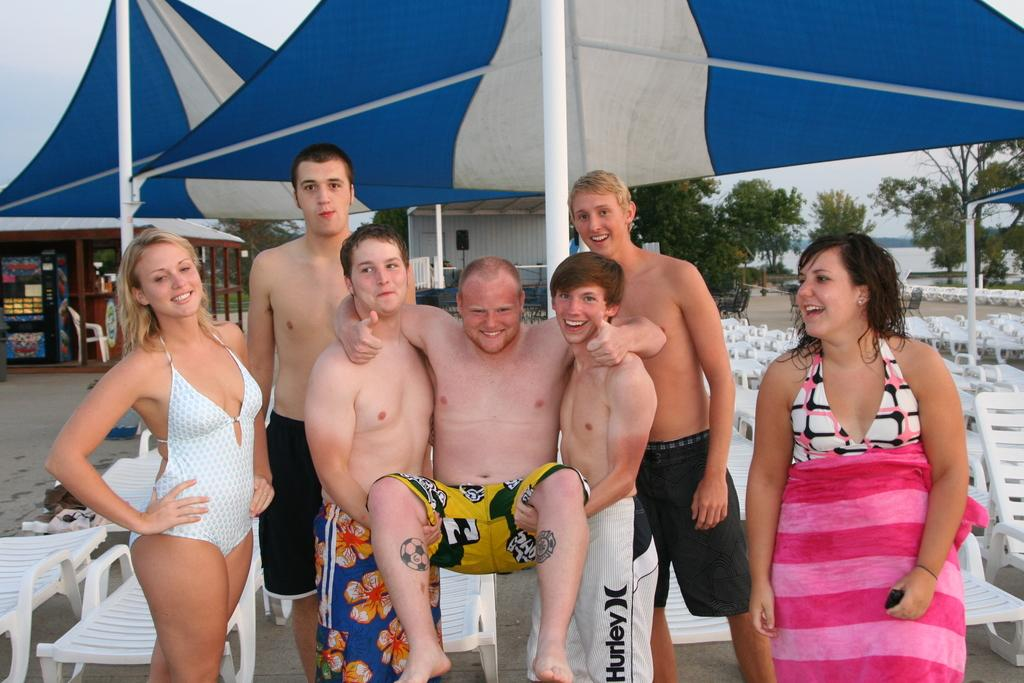What are the people in the image doing? The people in the image are standing and smiling. What objects are visible in the image that people might sit on? Chairs are visible in the image that people might sit on. What type of shelter is present in the image? Tents are visible in the image as a type of shelter. What type of vegetation is present in the image? Trees are present in the image. What type of structures are visible in the image? Sheds are visible in the image. What design is featured on the turkey in the image? There is no turkey present in the image, so there is no design to describe. 